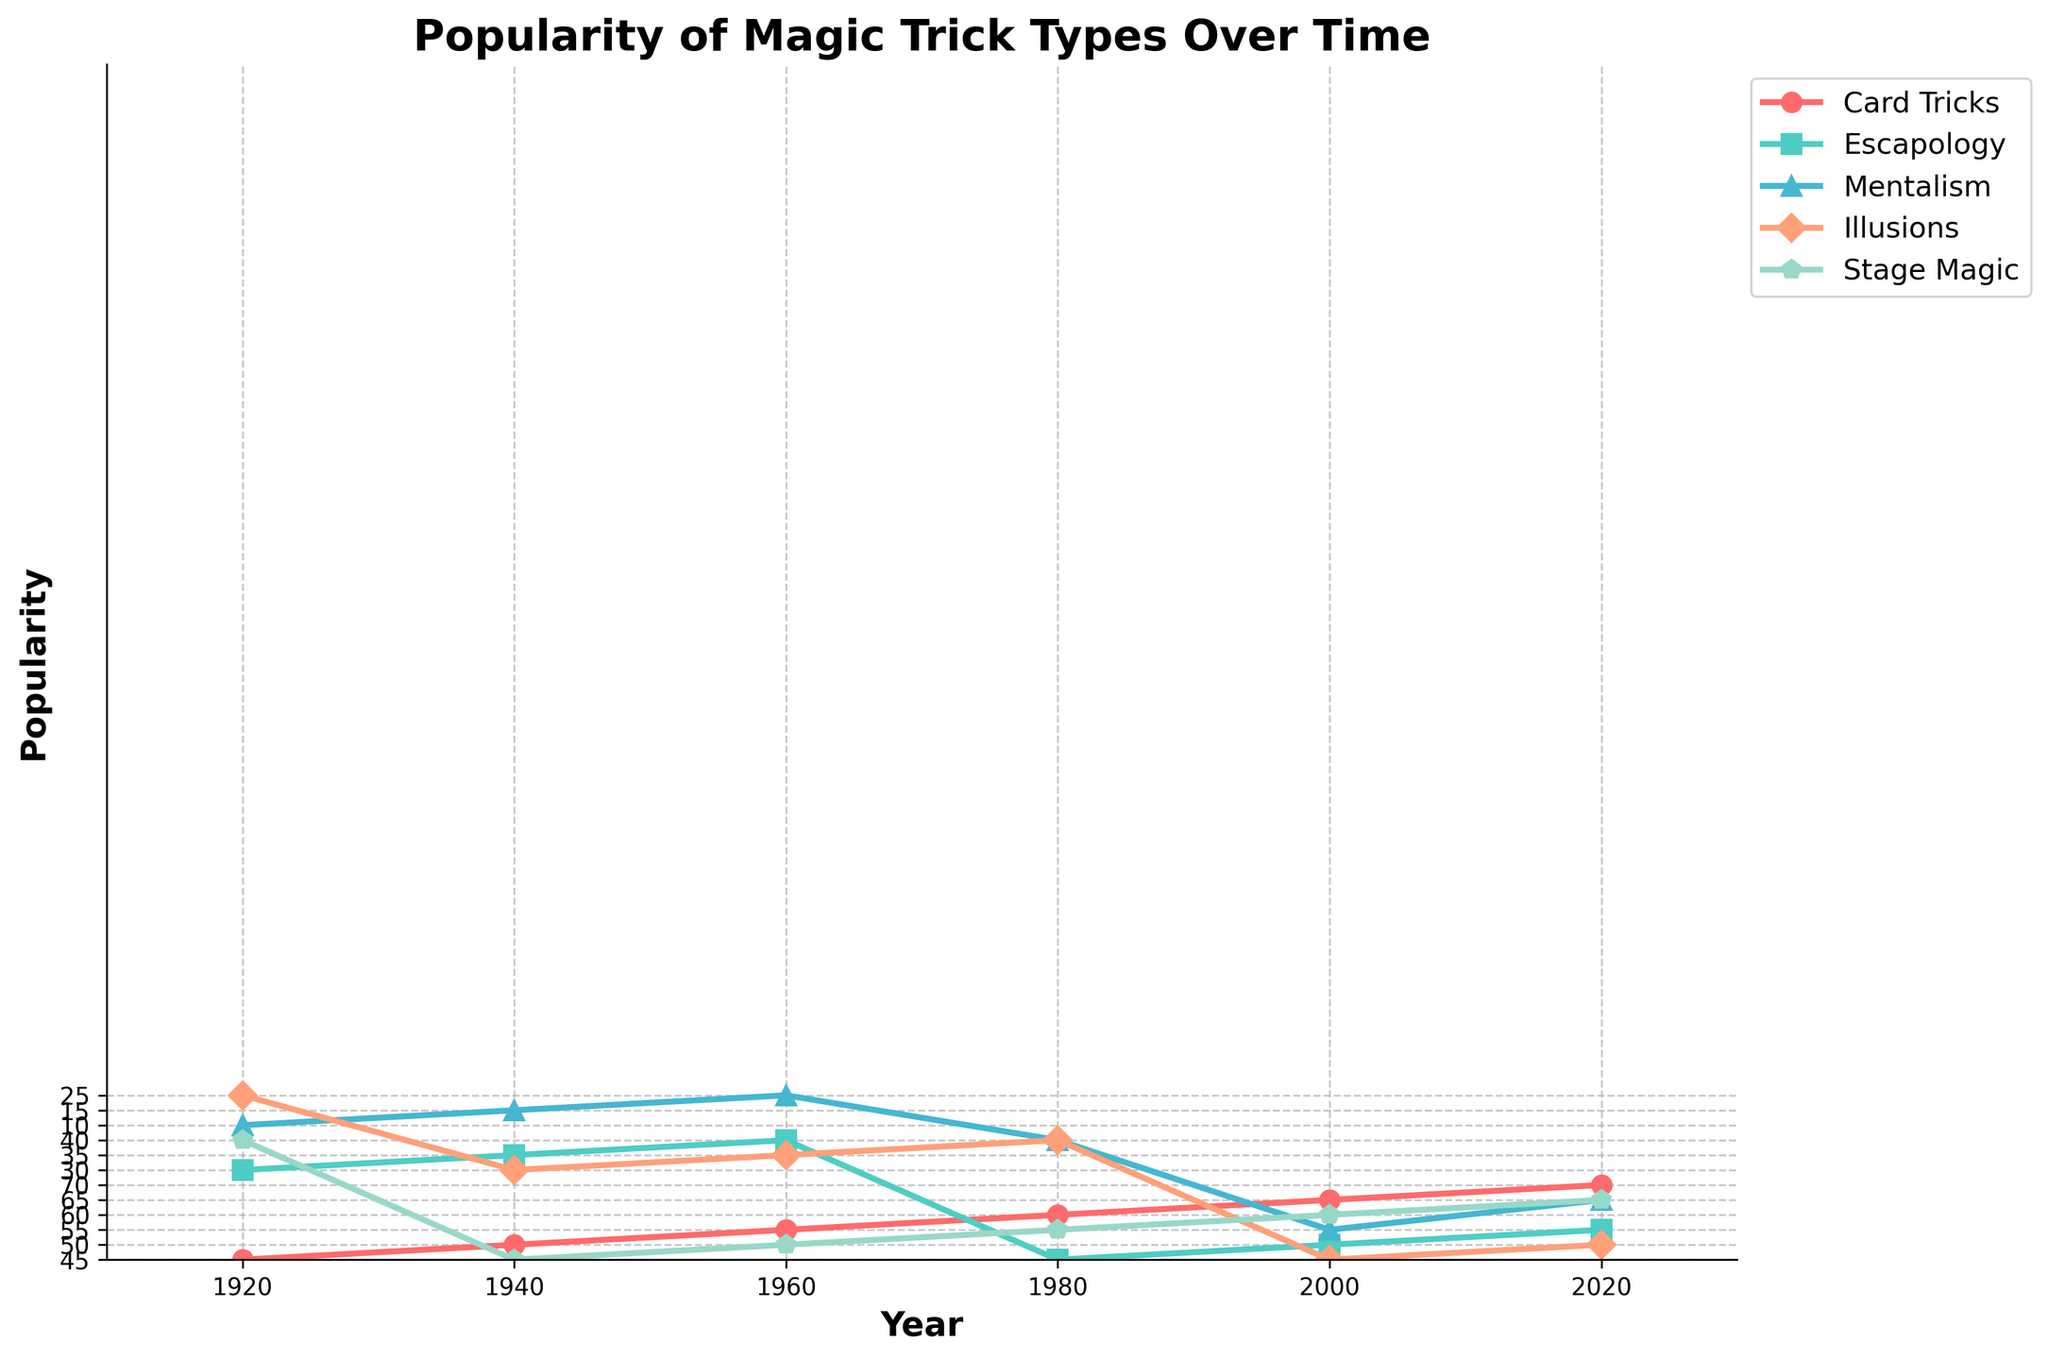What is the overall trend in the popularity of Card Tricks from 1920 to 2020? The plot shows the popularity of "Card Tricks" increasing steadily from 45 in 1920 to 70 in 2020. This indicates a consistent upward trend over the century.
Answer: Increasing Among all trick types, which one had the highest increase in popularity from 1920 to 2020? By comparing the starting and ending values for each trick type, "Mentalism" increased the most, from 10 in 1920 to 65 in 2020, which is an increase of 55.
Answer: Mentalism Which geographical region shows the highest popularity for "Stage Magic" in 2020? Looking at the data for "Stage Magic" in 2020, the values are: North America (70), Europe (60), Asia (55), South America (50), and Africa (45). North America has the highest value.
Answer: North America What is the visual attribute used to differentiate different trick types on the plot? Each trick type is differentiated by unique colors and markers, such as 'red circles' for Card Tricks and 'green squares' for Escapology.
Answer: Colors and markers What is the difference in popularity of "Escapology" between North America and Asia in 1980? In 1980, North America had 50 in Escapology popularity while Asia had 35. The difference is 50 - 35 = 15.
Answer: 15 If the trend continues, what would be the expected popularity of "Illusions" in 2040? The popularity of Illusions increased by 5 units every 20 years (25 in 1920, 30 in 1940, 35 in 1960, etc.). Assuming this trend continues, popularity in 2040 would be 50 + 5 = 55.
Answer: 55 Which trick type saw the least popularity in Europe during the 1960s? The values show that "Mentalism" had a popularity of 20, which is the lowest among all trick types in Europe during the 1960s.
Answer: Mentalism What is the average popularity of "Card Tricks" across all regions in 2020? The popularity of Card Tricks in 2020 is: North America (75), Europe (65), Asia (60), South America (55), and Africa (50). The average is (75 + 65 + 60 + 55 + 50) / 5 = 61.
Answer: 61 Among the trick types, which one had the smallest visual marker in the figure? Based on the visual attributes, the smallest marker, represented by dots, is used for "Mentalism."
Answer: Mentalism 